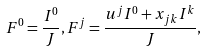Convert formula to latex. <formula><loc_0><loc_0><loc_500><loc_500>F ^ { 0 } = \frac { I ^ { 0 } } { J } , F ^ { j } = \frac { u ^ { j } I ^ { 0 } + x _ { j k } I ^ { k } } { J } ,</formula> 